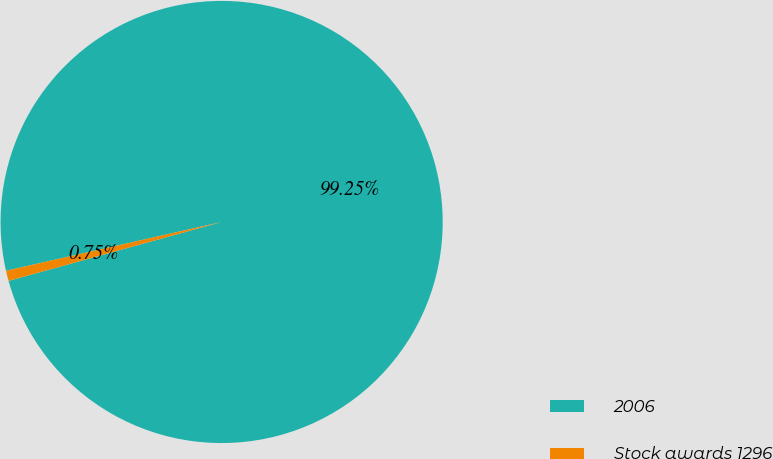Convert chart to OTSL. <chart><loc_0><loc_0><loc_500><loc_500><pie_chart><fcel>2006<fcel>Stock awards 1296<nl><fcel>99.25%<fcel>0.75%<nl></chart> 